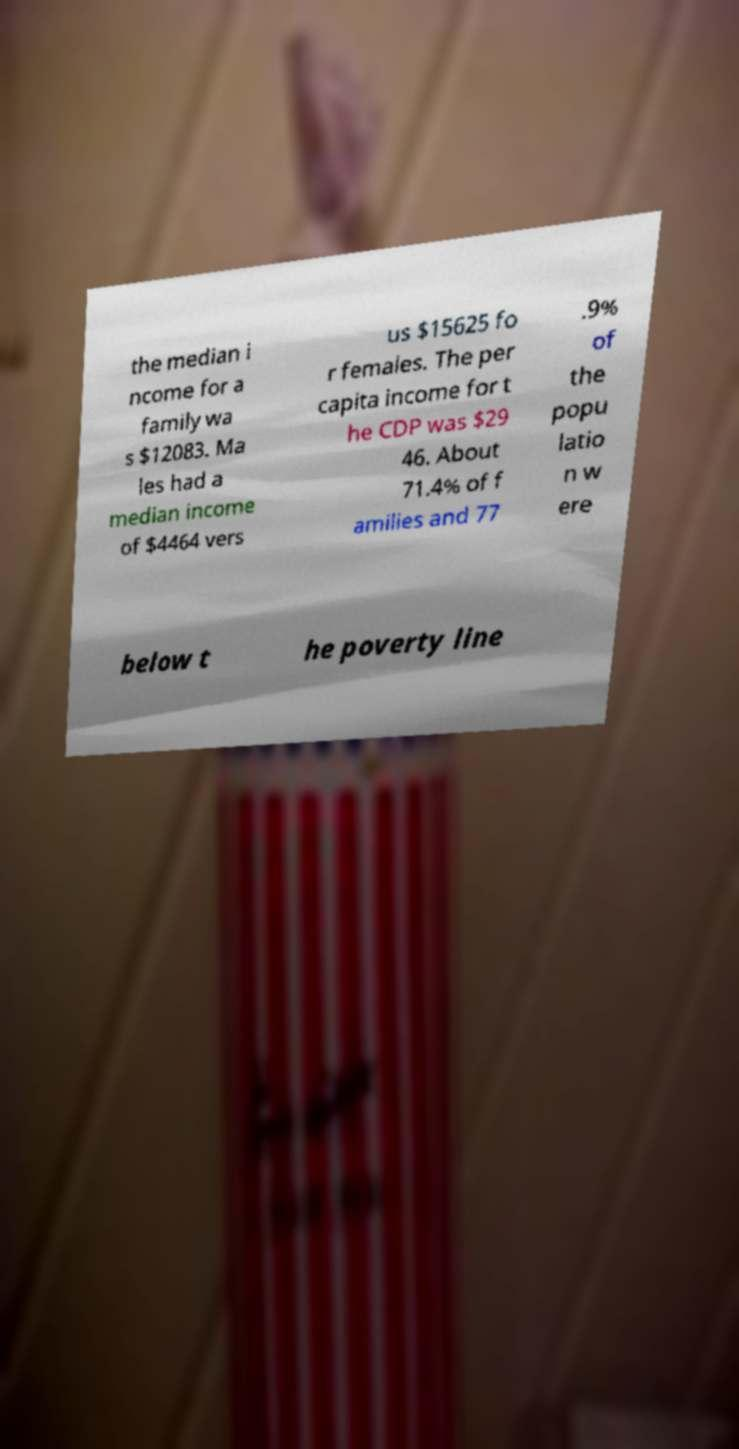Can you read and provide the text displayed in the image?This photo seems to have some interesting text. Can you extract and type it out for me? the median i ncome for a family wa s $12083. Ma les had a median income of $4464 vers us $15625 fo r females. The per capita income for t he CDP was $29 46. About 71.4% of f amilies and 77 .9% of the popu latio n w ere below t he poverty line 